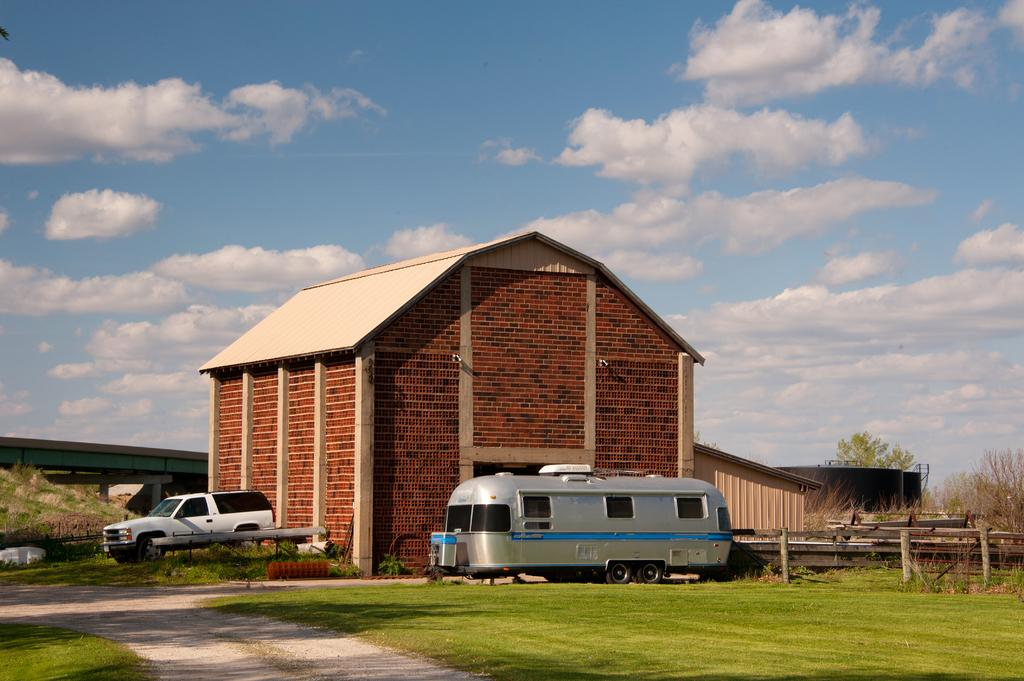How many vehicles are on the ground in the image? There are two vehicles on the ground in the image. What can be seen in the background of the image? There are houses, a bridge on the left side, a fence on the right side, trees, and clouds visible in the sky in the background. What type of stretch is the dad doing with his team in the image? There is no dad or team present in the image, and therefore no stretching activity can be observed. 